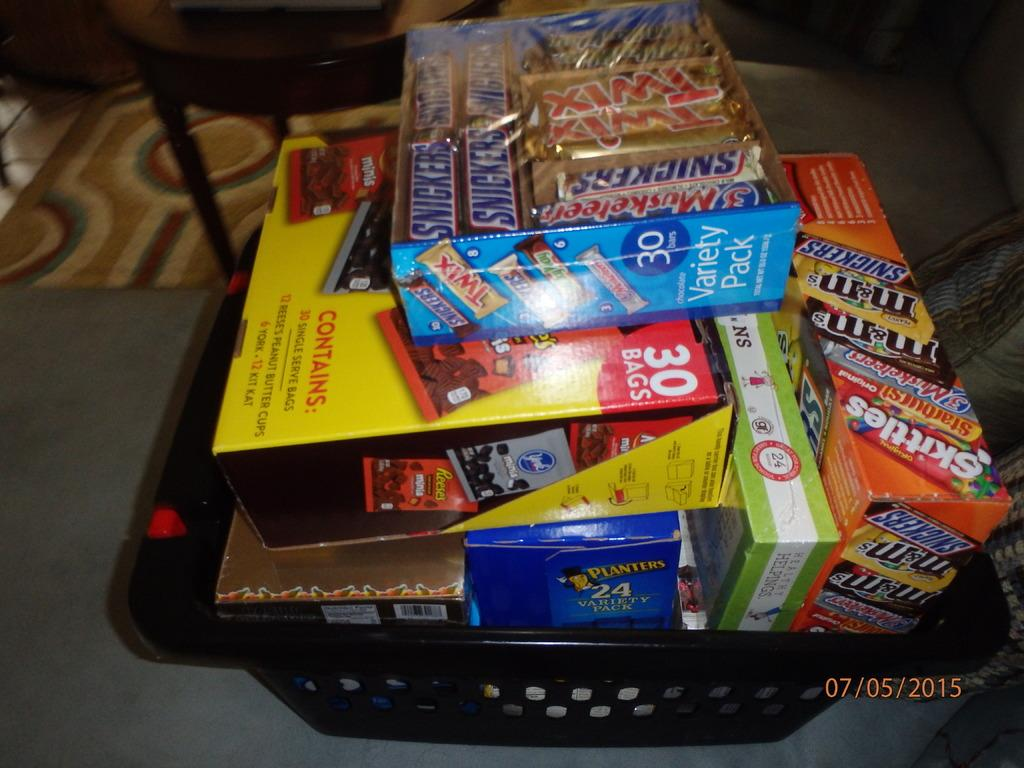<image>
Render a clear and concise summary of the photo. A laundry basket is full of snacks, a variety pack of 30 pieces of candy sitting on the top. 